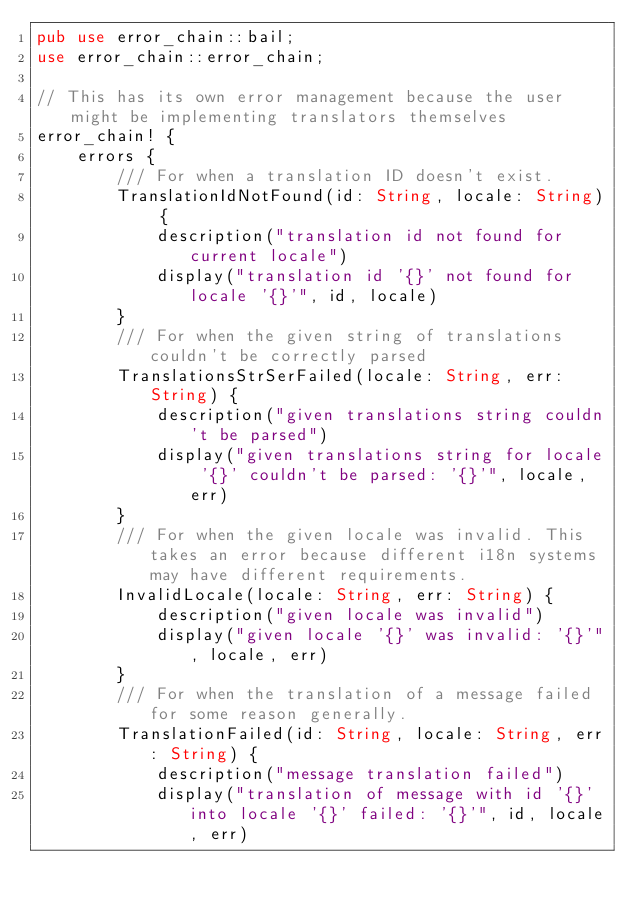Convert code to text. <code><loc_0><loc_0><loc_500><loc_500><_Rust_>pub use error_chain::bail;
use error_chain::error_chain;

// This has its own error management because the user might be implementing translators themselves
error_chain! {
    errors {
        /// For when a translation ID doesn't exist.
        TranslationIdNotFound(id: String, locale: String) {
            description("translation id not found for current locale")
            display("translation id '{}' not found for locale '{}'", id, locale)
        }
        /// For when the given string of translations couldn't be correctly parsed
        TranslationsStrSerFailed(locale: String, err: String) {
            description("given translations string couldn't be parsed")
            display("given translations string for locale '{}' couldn't be parsed: '{}'", locale, err)
        }
        /// For when the given locale was invalid. This takes an error because different i18n systems may have different requirements.
        InvalidLocale(locale: String, err: String) {
            description("given locale was invalid")
            display("given locale '{}' was invalid: '{}'", locale, err)
        }
        /// For when the translation of a message failed for some reason generally.
        TranslationFailed(id: String, locale: String, err: String) {
            description("message translation failed")
            display("translation of message with id '{}' into locale '{}' failed: '{}'", id, locale, err)</code> 